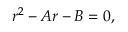Convert formula to latex. <formula><loc_0><loc_0><loc_500><loc_500>r ^ { 2 } - A r - B = 0 ,</formula> 